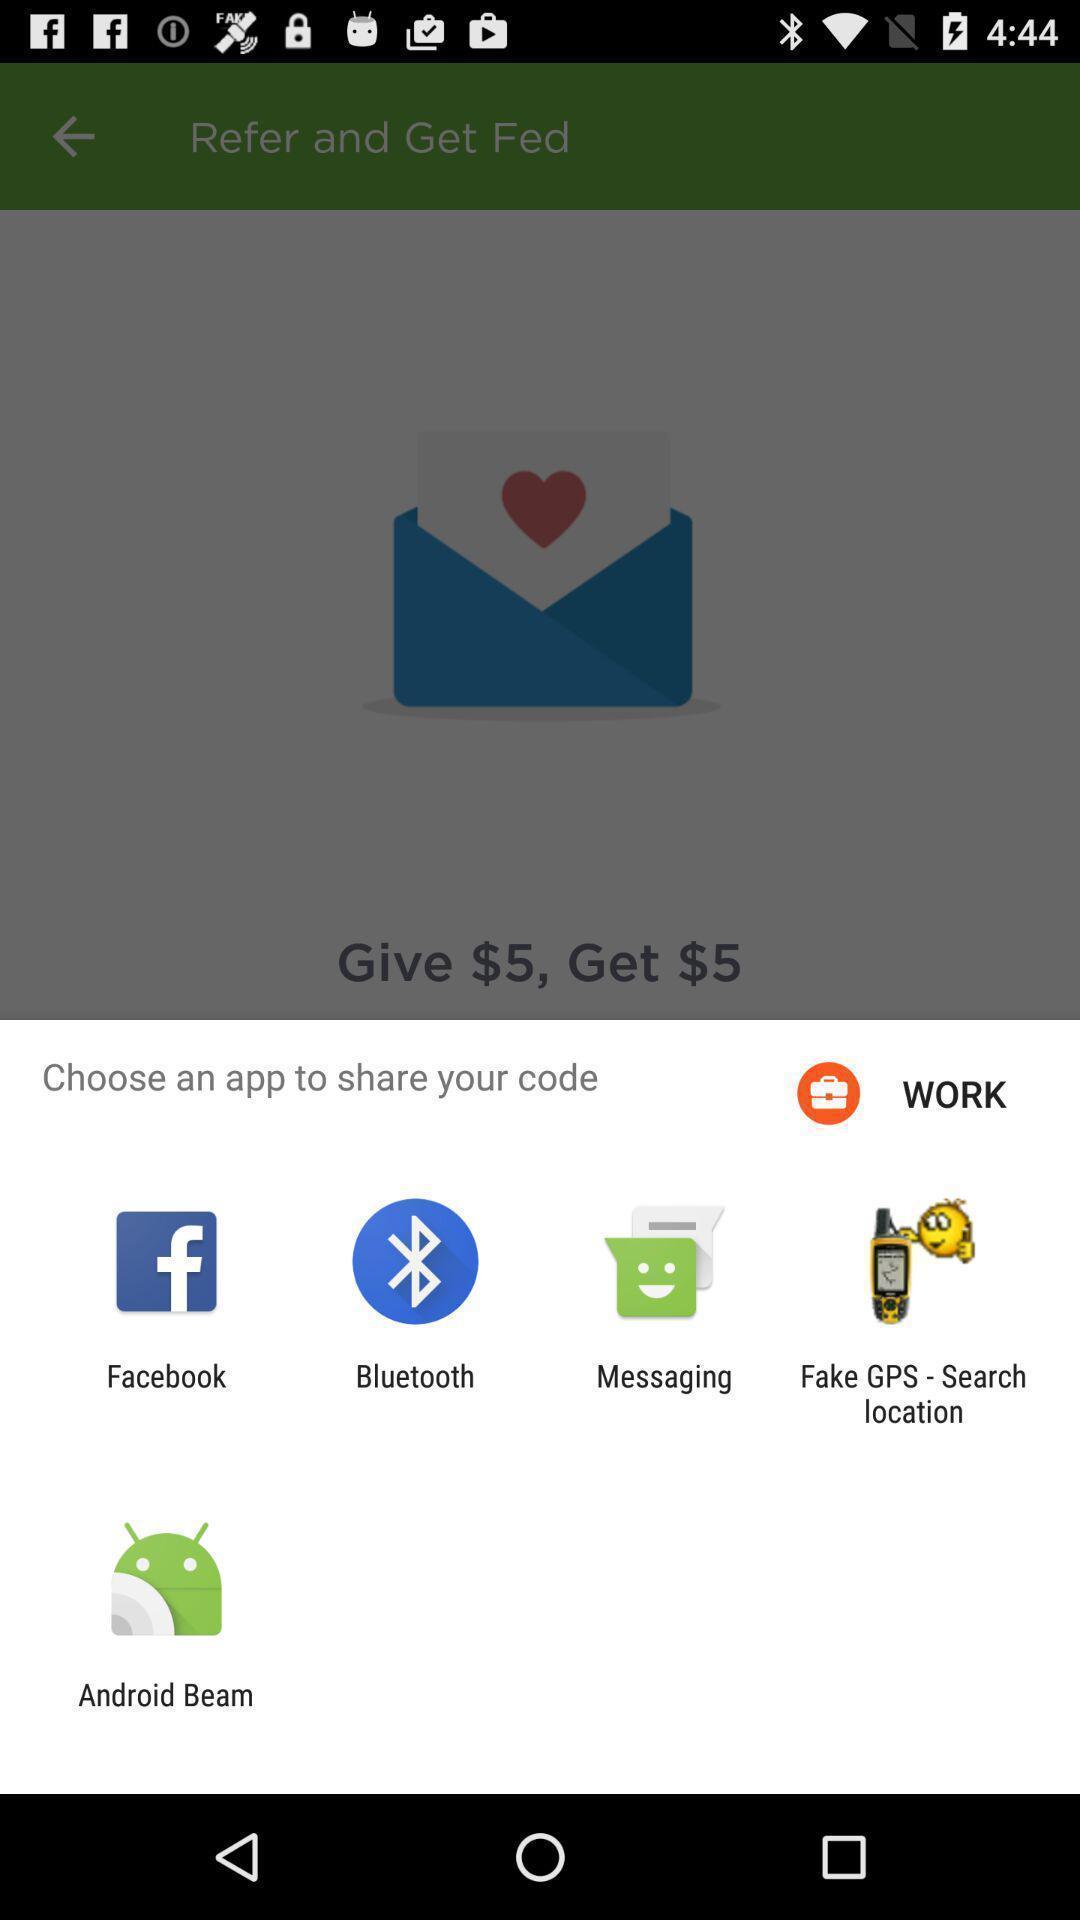What is the overall content of this screenshot? Popup displaying multiple options to choose an app. 